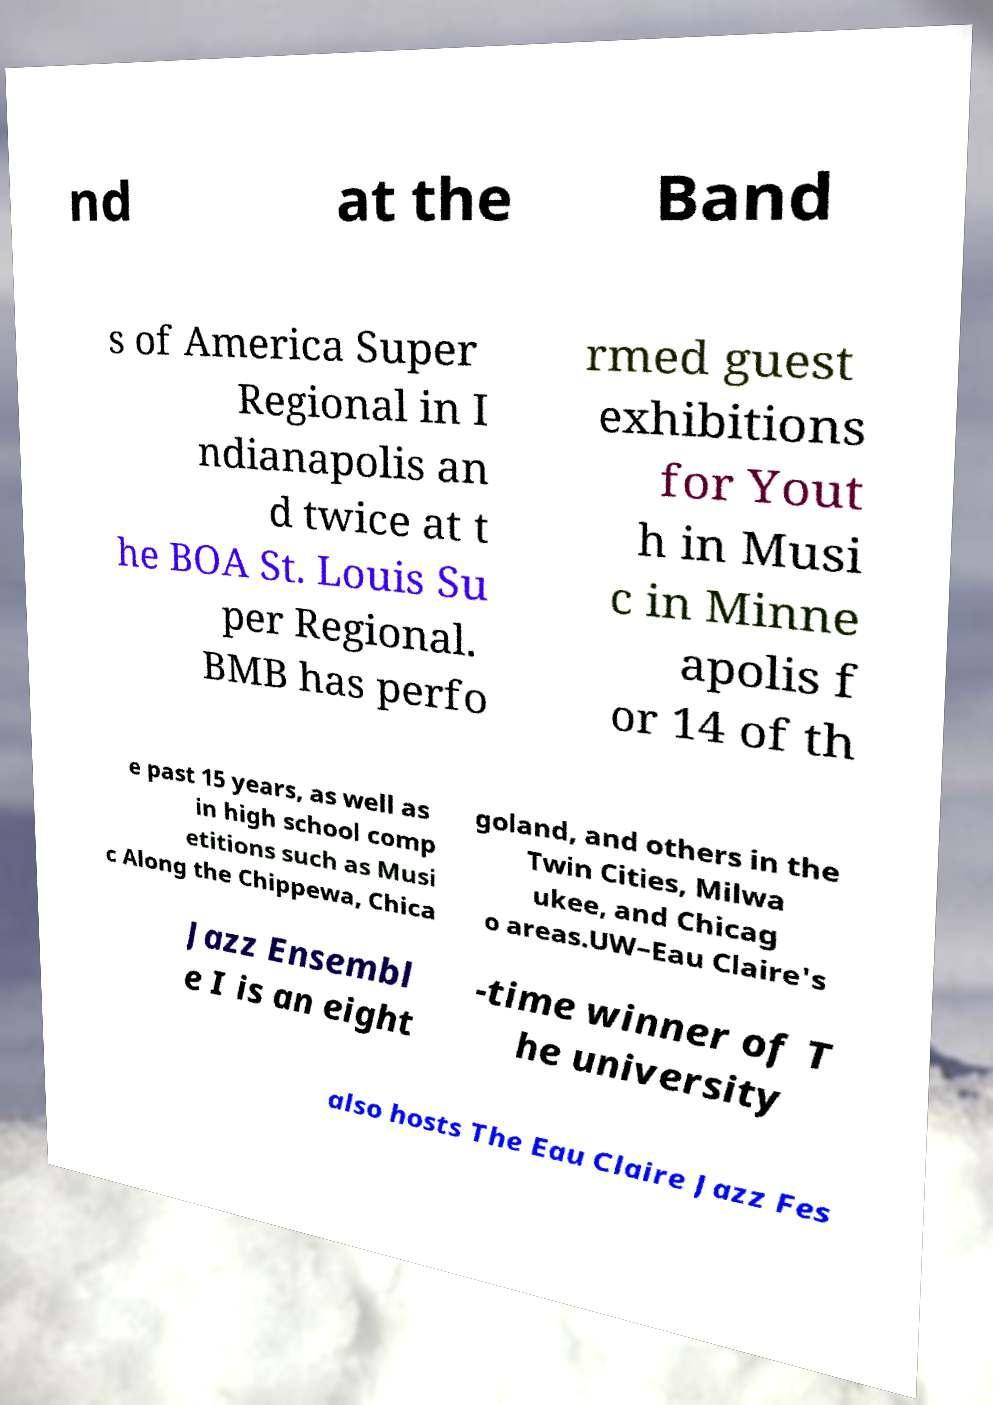Can you read and provide the text displayed in the image?This photo seems to have some interesting text. Can you extract and type it out for me? nd at the Band s of America Super Regional in I ndianapolis an d twice at t he BOA St. Louis Su per Regional. BMB has perfo rmed guest exhibitions for Yout h in Musi c in Minne apolis f or 14 of th e past 15 years, as well as in high school comp etitions such as Musi c Along the Chippewa, Chica goland, and others in the Twin Cities, Milwa ukee, and Chicag o areas.UW–Eau Claire's Jazz Ensembl e I is an eight -time winner of T he university also hosts The Eau Claire Jazz Fes 